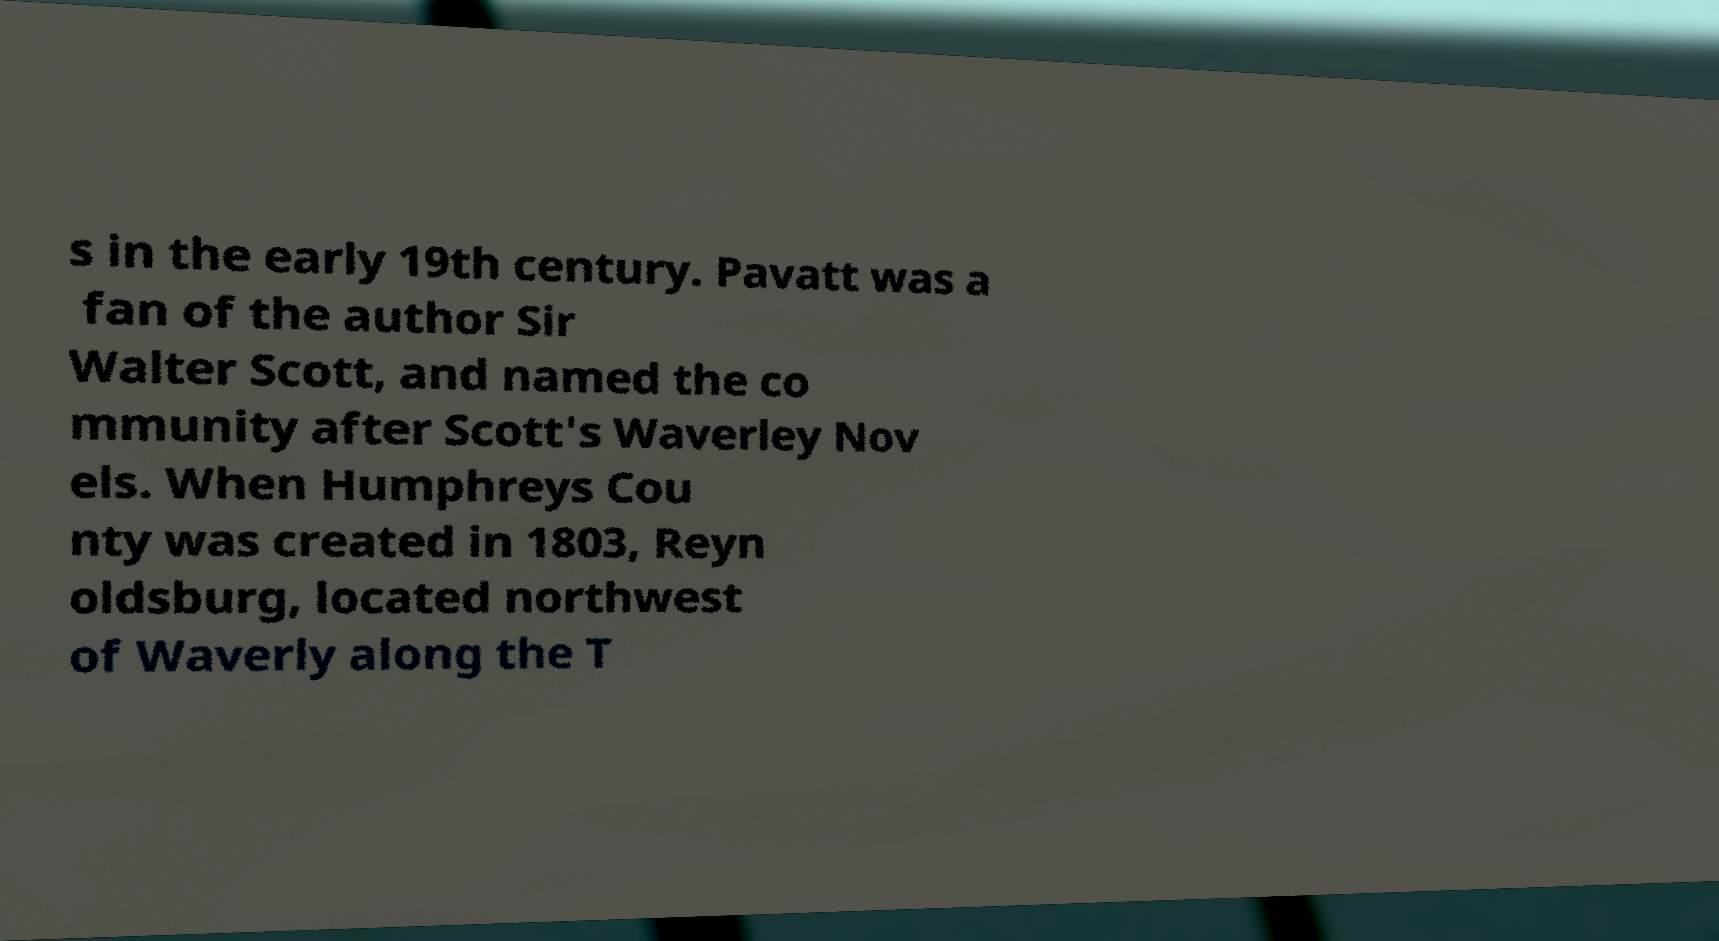Please read and relay the text visible in this image. What does it say? s in the early 19th century. Pavatt was a fan of the author Sir Walter Scott, and named the co mmunity after Scott's Waverley Nov els. When Humphreys Cou nty was created in 1803, Reyn oldsburg, located northwest of Waverly along the T 